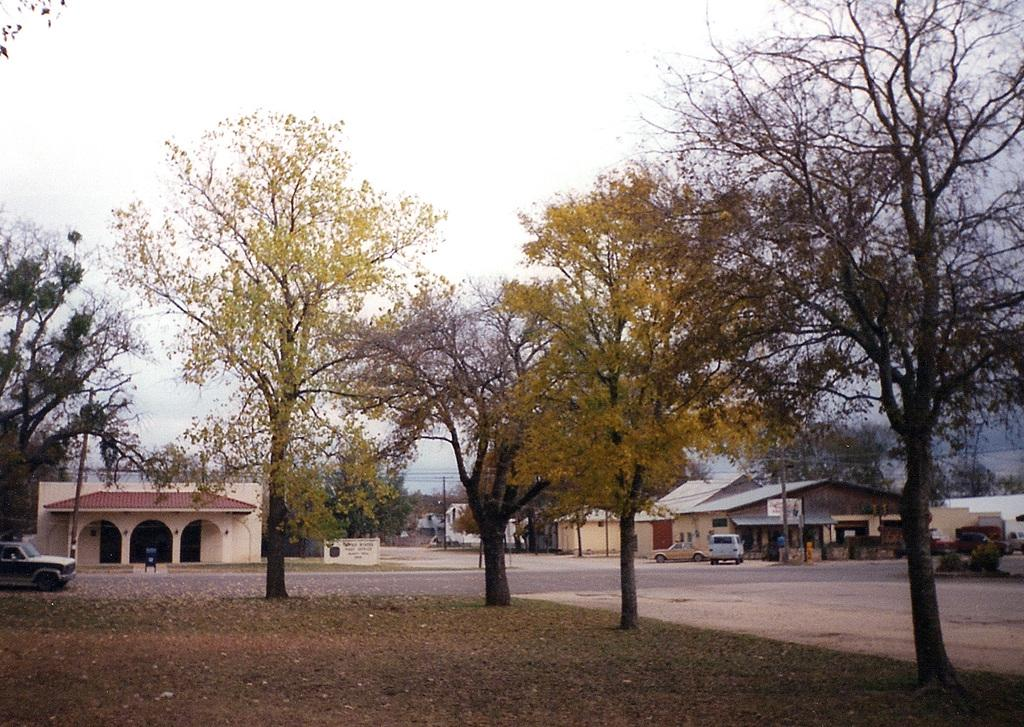What type of landscape is visible in the foreground of the image? There is a grassland and trees in the foreground of the image. What can be seen in the background of the image? There are vehicles, buildings, poles, cables, and the sky visible in the background of the image. What action is the support performing in the image? There is no support performing any action in the image, as the poles and cables mentioned in the facts are not described as performing any action. How does the image show an increase in the number of trees? The image does not show an increase in the number of trees; it only depicts the current number of trees present in the foreground. 